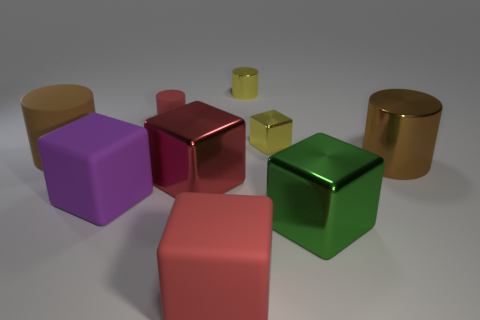Add 1 gray rubber cylinders. How many objects exist? 10 Subtract all blocks. How many objects are left? 4 Subtract 1 cylinders. How many cylinders are left? 3 Subtract all brown cylinders. How many cylinders are left? 2 Subtract all big purple cubes. How many cubes are left? 4 Subtract 1 red cylinders. How many objects are left? 8 Subtract all gray cylinders. Subtract all gray balls. How many cylinders are left? 4 Subtract all green balls. How many purple cubes are left? 1 Subtract all shiny things. Subtract all brown things. How many objects are left? 2 Add 5 small red rubber cylinders. How many small red rubber cylinders are left? 6 